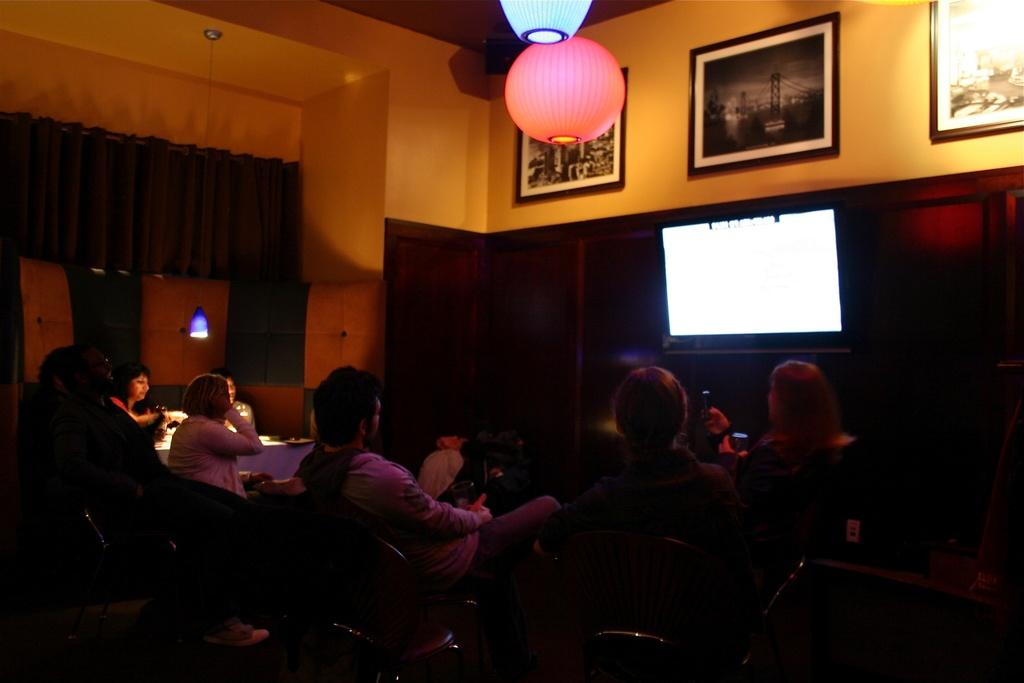How many people are in the image? There is a group of people in the image. What are the people doing in the image? The people are seated on chairs. What is in front of the people? There is a monitor in front of the people. What can be seen on the wall in the image? There are paintings on the wall. What can be seen providing illumination in the image? There are lights visible in the image. How many trucks are parked outside the room in the image? There is no information about trucks or any outdoor setting in the image; it only shows a group of people seated with a monitor and paintings on the wall. 